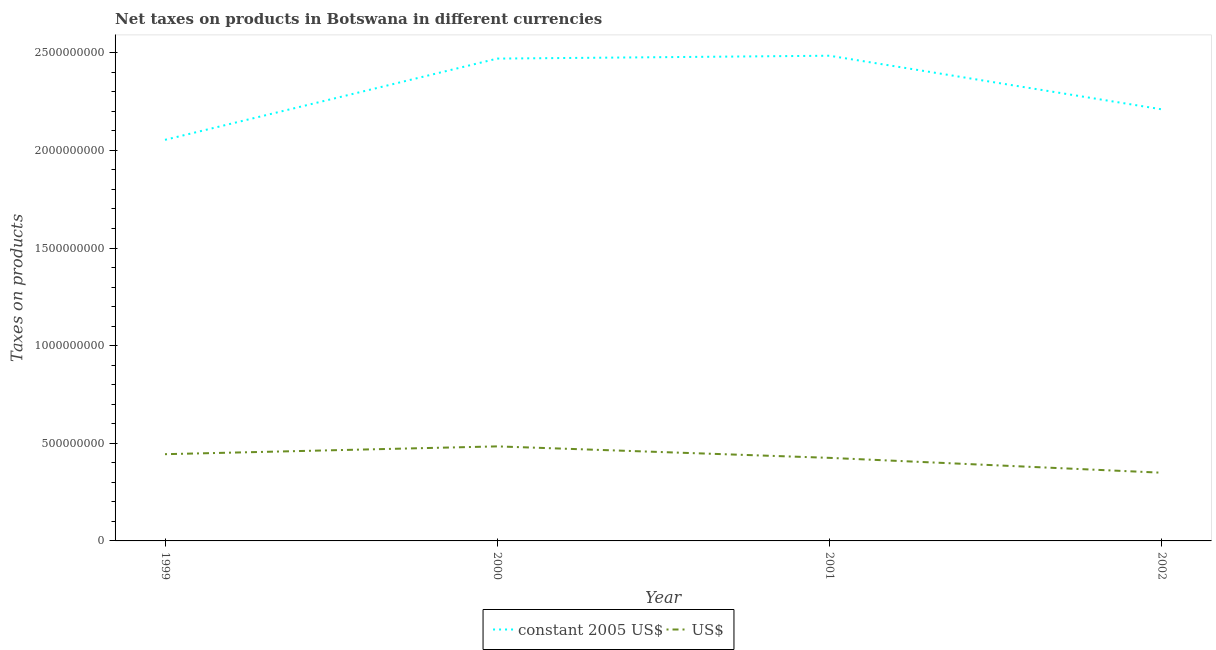How many different coloured lines are there?
Provide a succinct answer. 2. What is the net taxes in constant 2005 us$ in 1999?
Ensure brevity in your answer.  2.05e+09. Across all years, what is the maximum net taxes in constant 2005 us$?
Provide a short and direct response. 2.48e+09. Across all years, what is the minimum net taxes in us$?
Your response must be concise. 3.49e+08. What is the total net taxes in us$ in the graph?
Make the answer very short. 1.70e+09. What is the difference between the net taxes in constant 2005 us$ in 2000 and that in 2002?
Make the answer very short. 2.60e+08. What is the difference between the net taxes in constant 2005 us$ in 2002 and the net taxes in us$ in 1999?
Provide a succinct answer. 1.77e+09. What is the average net taxes in us$ per year?
Make the answer very short. 4.26e+08. In the year 2001, what is the difference between the net taxes in constant 2005 us$ and net taxes in us$?
Offer a terse response. 2.06e+09. What is the ratio of the net taxes in constant 2005 us$ in 2001 to that in 2002?
Offer a very short reply. 1.12. Is the net taxes in constant 2005 us$ in 2001 less than that in 2002?
Make the answer very short. No. What is the difference between the highest and the second highest net taxes in constant 2005 us$?
Ensure brevity in your answer.  1.47e+07. What is the difference between the highest and the lowest net taxes in us$?
Provide a short and direct response. 1.35e+08. In how many years, is the net taxes in us$ greater than the average net taxes in us$ taken over all years?
Provide a succinct answer. 2. Is the net taxes in us$ strictly less than the net taxes in constant 2005 us$ over the years?
Provide a short and direct response. Yes. How many lines are there?
Your answer should be very brief. 2. Are the values on the major ticks of Y-axis written in scientific E-notation?
Offer a terse response. No. Does the graph contain any zero values?
Ensure brevity in your answer.  No. Does the graph contain grids?
Provide a short and direct response. No. What is the title of the graph?
Offer a terse response. Net taxes on products in Botswana in different currencies. What is the label or title of the X-axis?
Offer a terse response. Year. What is the label or title of the Y-axis?
Provide a succinct answer. Taxes on products. What is the Taxes on products in constant 2005 US$ in 1999?
Provide a short and direct response. 2.05e+09. What is the Taxes on products of US$ in 1999?
Give a very brief answer. 4.44e+08. What is the Taxes on products in constant 2005 US$ in 2000?
Offer a terse response. 2.47e+09. What is the Taxes on products of US$ in 2000?
Your response must be concise. 4.84e+08. What is the Taxes on products of constant 2005 US$ in 2001?
Provide a short and direct response. 2.48e+09. What is the Taxes on products of US$ in 2001?
Your answer should be very brief. 4.25e+08. What is the Taxes on products of constant 2005 US$ in 2002?
Your answer should be compact. 2.21e+09. What is the Taxes on products of US$ in 2002?
Provide a succinct answer. 3.49e+08. Across all years, what is the maximum Taxes on products of constant 2005 US$?
Offer a terse response. 2.48e+09. Across all years, what is the maximum Taxes on products in US$?
Make the answer very short. 4.84e+08. Across all years, what is the minimum Taxes on products in constant 2005 US$?
Give a very brief answer. 2.05e+09. Across all years, what is the minimum Taxes on products of US$?
Your response must be concise. 3.49e+08. What is the total Taxes on products of constant 2005 US$ in the graph?
Ensure brevity in your answer.  9.22e+09. What is the total Taxes on products in US$ in the graph?
Provide a short and direct response. 1.70e+09. What is the difference between the Taxes on products in constant 2005 US$ in 1999 and that in 2000?
Offer a very short reply. -4.16e+08. What is the difference between the Taxes on products of US$ in 1999 and that in 2000?
Your answer should be very brief. -4.00e+07. What is the difference between the Taxes on products of constant 2005 US$ in 1999 and that in 2001?
Provide a short and direct response. -4.31e+08. What is the difference between the Taxes on products of US$ in 1999 and that in 2001?
Provide a short and direct response. 1.88e+07. What is the difference between the Taxes on products in constant 2005 US$ in 1999 and that in 2002?
Your answer should be very brief. -1.56e+08. What is the difference between the Taxes on products of US$ in 1999 and that in 2002?
Make the answer very short. 9.49e+07. What is the difference between the Taxes on products of constant 2005 US$ in 2000 and that in 2001?
Ensure brevity in your answer.  -1.47e+07. What is the difference between the Taxes on products of US$ in 2000 and that in 2001?
Keep it short and to the point. 5.88e+07. What is the difference between the Taxes on products of constant 2005 US$ in 2000 and that in 2002?
Offer a terse response. 2.60e+08. What is the difference between the Taxes on products of US$ in 2000 and that in 2002?
Offer a very short reply. 1.35e+08. What is the difference between the Taxes on products in constant 2005 US$ in 2001 and that in 2002?
Your answer should be very brief. 2.74e+08. What is the difference between the Taxes on products in US$ in 2001 and that in 2002?
Keep it short and to the point. 7.61e+07. What is the difference between the Taxes on products in constant 2005 US$ in 1999 and the Taxes on products in US$ in 2000?
Provide a short and direct response. 1.57e+09. What is the difference between the Taxes on products in constant 2005 US$ in 1999 and the Taxes on products in US$ in 2001?
Offer a very short reply. 1.63e+09. What is the difference between the Taxes on products in constant 2005 US$ in 1999 and the Taxes on products in US$ in 2002?
Your answer should be very brief. 1.70e+09. What is the difference between the Taxes on products in constant 2005 US$ in 2000 and the Taxes on products in US$ in 2001?
Make the answer very short. 2.04e+09. What is the difference between the Taxes on products in constant 2005 US$ in 2000 and the Taxes on products in US$ in 2002?
Provide a succinct answer. 2.12e+09. What is the difference between the Taxes on products in constant 2005 US$ in 2001 and the Taxes on products in US$ in 2002?
Provide a short and direct response. 2.14e+09. What is the average Taxes on products in constant 2005 US$ per year?
Your answer should be compact. 2.30e+09. What is the average Taxes on products in US$ per year?
Provide a short and direct response. 4.26e+08. In the year 1999, what is the difference between the Taxes on products of constant 2005 US$ and Taxes on products of US$?
Make the answer very short. 1.61e+09. In the year 2000, what is the difference between the Taxes on products of constant 2005 US$ and Taxes on products of US$?
Make the answer very short. 1.99e+09. In the year 2001, what is the difference between the Taxes on products in constant 2005 US$ and Taxes on products in US$?
Your answer should be very brief. 2.06e+09. In the year 2002, what is the difference between the Taxes on products in constant 2005 US$ and Taxes on products in US$?
Provide a short and direct response. 1.86e+09. What is the ratio of the Taxes on products of constant 2005 US$ in 1999 to that in 2000?
Your answer should be very brief. 0.83. What is the ratio of the Taxes on products of US$ in 1999 to that in 2000?
Your response must be concise. 0.92. What is the ratio of the Taxes on products of constant 2005 US$ in 1999 to that in 2001?
Give a very brief answer. 0.83. What is the ratio of the Taxes on products in US$ in 1999 to that in 2001?
Provide a short and direct response. 1.04. What is the ratio of the Taxes on products of constant 2005 US$ in 1999 to that in 2002?
Provide a succinct answer. 0.93. What is the ratio of the Taxes on products of US$ in 1999 to that in 2002?
Your answer should be compact. 1.27. What is the ratio of the Taxes on products of constant 2005 US$ in 2000 to that in 2001?
Provide a succinct answer. 0.99. What is the ratio of the Taxes on products in US$ in 2000 to that in 2001?
Your answer should be compact. 1.14. What is the ratio of the Taxes on products in constant 2005 US$ in 2000 to that in 2002?
Give a very brief answer. 1.12. What is the ratio of the Taxes on products in US$ in 2000 to that in 2002?
Your answer should be compact. 1.39. What is the ratio of the Taxes on products of constant 2005 US$ in 2001 to that in 2002?
Your answer should be very brief. 1.12. What is the ratio of the Taxes on products in US$ in 2001 to that in 2002?
Ensure brevity in your answer.  1.22. What is the difference between the highest and the second highest Taxes on products in constant 2005 US$?
Your answer should be very brief. 1.47e+07. What is the difference between the highest and the second highest Taxes on products in US$?
Provide a short and direct response. 4.00e+07. What is the difference between the highest and the lowest Taxes on products in constant 2005 US$?
Offer a terse response. 4.31e+08. What is the difference between the highest and the lowest Taxes on products of US$?
Provide a short and direct response. 1.35e+08. 